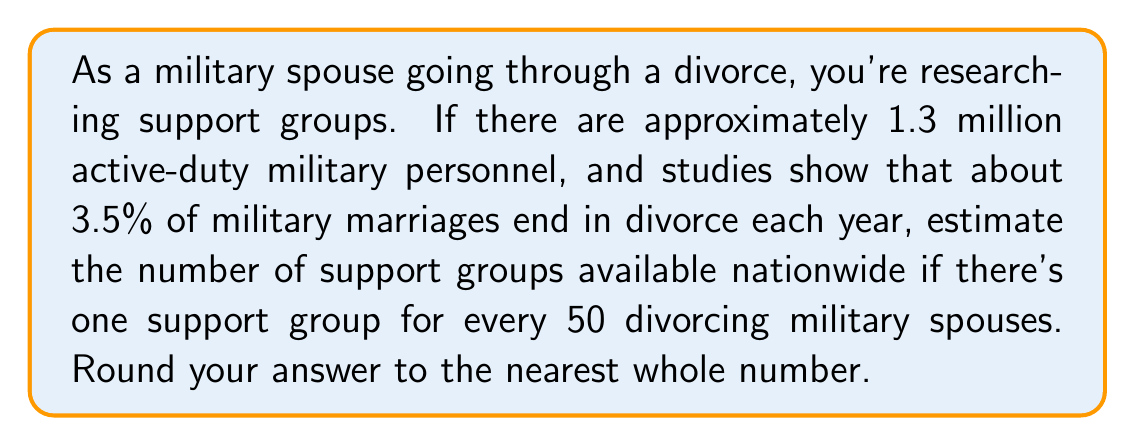Give your solution to this math problem. Let's break this problem down step-by-step:

1. Calculate the number of military divorces per year:
   $$ \text{Number of divorces} = \text{Total active-duty personnel} \times \text{Divorce rate} $$
   $$ = 1,300,000 \times 0.035 = 45,500 $$

2. Determine the number of support groups:
   We assume one support group for every 50 divorcing military spouses.
   $$ \text{Number of support groups} = \frac{\text{Number of divorces}}{\text{Spouses per group}} $$
   $$ = \frac{45,500}{50} = 910 $$

3. Round to the nearest whole number:
   910 is already a whole number, so no rounding is necessary.

Therefore, we estimate there are approximately 910 support groups available nationwide for military spouses going through divorce.
Answer: 910 support groups 